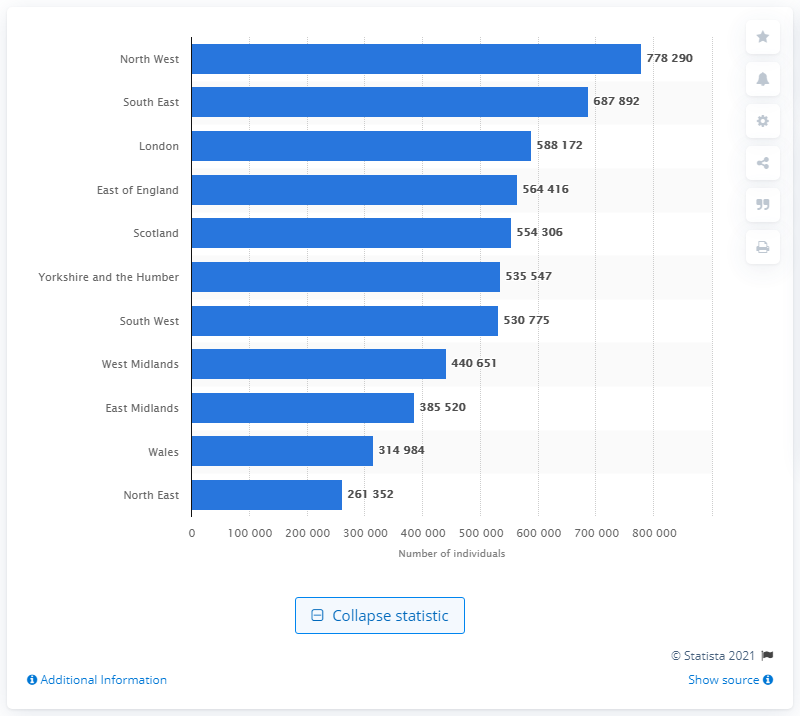What is the difference in asthma cases between the South East and Scotland? The South East has 687,892 individuals with asthma, while Scotland has 554,306 individuals. Therefore, the difference is 133,586. 